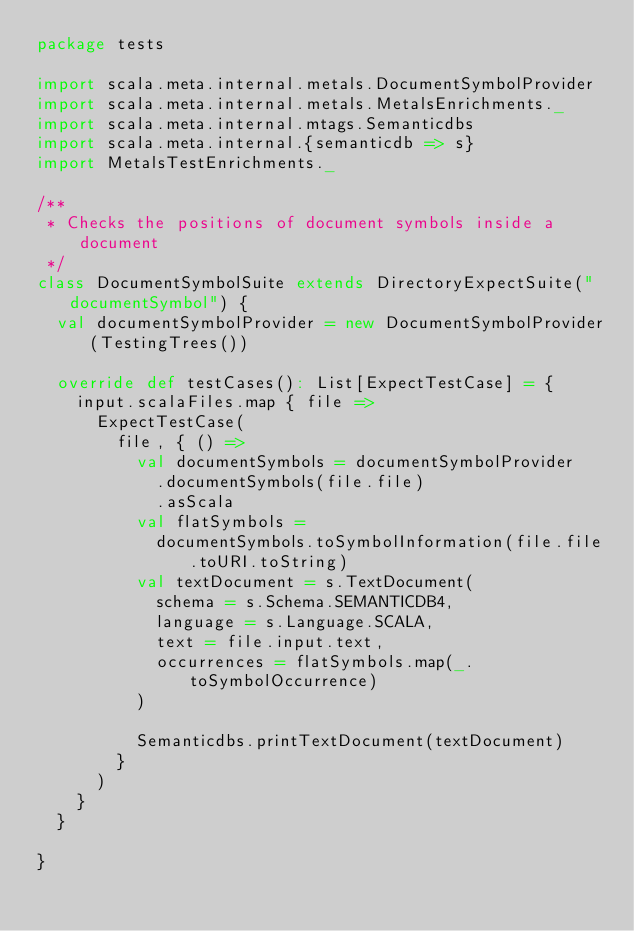Convert code to text. <code><loc_0><loc_0><loc_500><loc_500><_Scala_>package tests

import scala.meta.internal.metals.DocumentSymbolProvider
import scala.meta.internal.metals.MetalsEnrichments._
import scala.meta.internal.mtags.Semanticdbs
import scala.meta.internal.{semanticdb => s}
import MetalsTestEnrichments._

/**
 * Checks the positions of document symbols inside a document
 */
class DocumentSymbolSuite extends DirectoryExpectSuite("documentSymbol") {
  val documentSymbolProvider = new DocumentSymbolProvider(TestingTrees())

  override def testCases(): List[ExpectTestCase] = {
    input.scalaFiles.map { file =>
      ExpectTestCase(
        file, { () =>
          val documentSymbols = documentSymbolProvider
            .documentSymbols(file.file)
            .asScala
          val flatSymbols =
            documentSymbols.toSymbolInformation(file.file.toURI.toString)
          val textDocument = s.TextDocument(
            schema = s.Schema.SEMANTICDB4,
            language = s.Language.SCALA,
            text = file.input.text,
            occurrences = flatSymbols.map(_.toSymbolOccurrence)
          )

          Semanticdbs.printTextDocument(textDocument)
        }
      )
    }
  }

}
</code> 